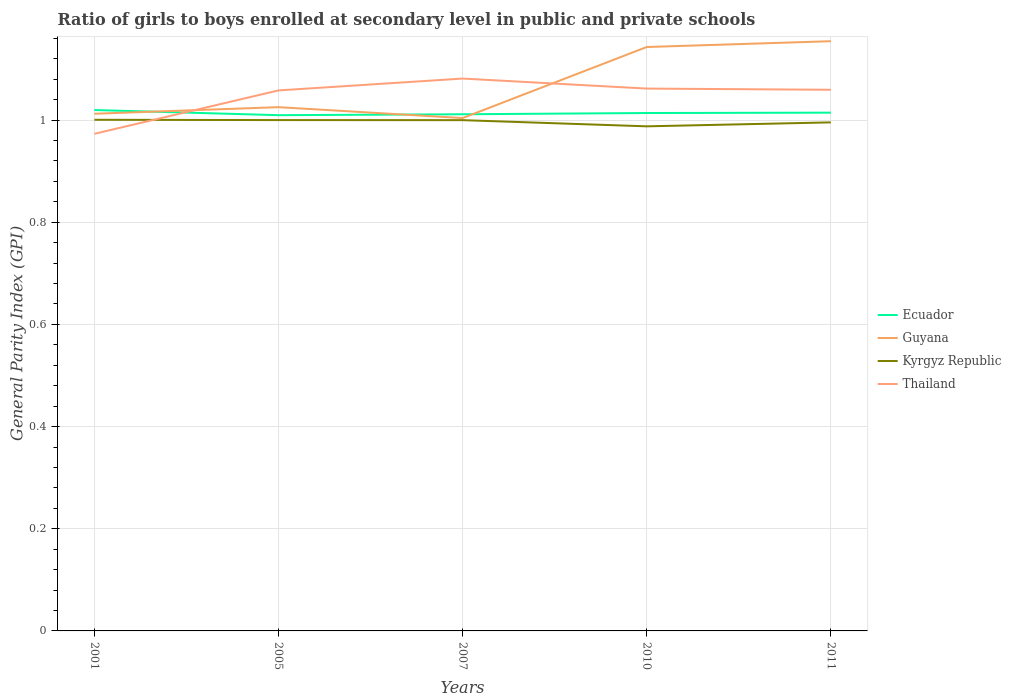How many different coloured lines are there?
Ensure brevity in your answer.  4. Is the number of lines equal to the number of legend labels?
Your answer should be compact. Yes. Across all years, what is the maximum general parity index in Ecuador?
Make the answer very short. 1.01. In which year was the general parity index in Kyrgyz Republic maximum?
Offer a terse response. 2010. What is the total general parity index in Guyana in the graph?
Provide a short and direct response. -0.13. What is the difference between the highest and the second highest general parity index in Kyrgyz Republic?
Your response must be concise. 0.01. What is the difference between the highest and the lowest general parity index in Thailand?
Your response must be concise. 4. What is the difference between two consecutive major ticks on the Y-axis?
Ensure brevity in your answer.  0.2. Does the graph contain any zero values?
Keep it short and to the point. No. Does the graph contain grids?
Provide a short and direct response. Yes. Where does the legend appear in the graph?
Provide a succinct answer. Center right. How many legend labels are there?
Keep it short and to the point. 4. What is the title of the graph?
Your answer should be very brief. Ratio of girls to boys enrolled at secondary level in public and private schools. What is the label or title of the Y-axis?
Offer a terse response. General Parity Index (GPI). What is the General Parity Index (GPI) in Ecuador in 2001?
Provide a short and direct response. 1.02. What is the General Parity Index (GPI) of Guyana in 2001?
Your response must be concise. 1.01. What is the General Parity Index (GPI) of Kyrgyz Republic in 2001?
Make the answer very short. 1. What is the General Parity Index (GPI) in Thailand in 2001?
Give a very brief answer. 0.97. What is the General Parity Index (GPI) in Ecuador in 2005?
Provide a succinct answer. 1.01. What is the General Parity Index (GPI) of Guyana in 2005?
Offer a terse response. 1.03. What is the General Parity Index (GPI) of Kyrgyz Republic in 2005?
Ensure brevity in your answer.  1. What is the General Parity Index (GPI) in Thailand in 2005?
Give a very brief answer. 1.06. What is the General Parity Index (GPI) in Ecuador in 2007?
Give a very brief answer. 1.01. What is the General Parity Index (GPI) in Guyana in 2007?
Make the answer very short. 1. What is the General Parity Index (GPI) of Kyrgyz Republic in 2007?
Keep it short and to the point. 1. What is the General Parity Index (GPI) of Thailand in 2007?
Your answer should be very brief. 1.08. What is the General Parity Index (GPI) in Ecuador in 2010?
Ensure brevity in your answer.  1.01. What is the General Parity Index (GPI) in Guyana in 2010?
Provide a short and direct response. 1.14. What is the General Parity Index (GPI) of Kyrgyz Republic in 2010?
Provide a succinct answer. 0.99. What is the General Parity Index (GPI) in Thailand in 2010?
Give a very brief answer. 1.06. What is the General Parity Index (GPI) of Ecuador in 2011?
Give a very brief answer. 1.01. What is the General Parity Index (GPI) of Guyana in 2011?
Offer a terse response. 1.15. What is the General Parity Index (GPI) in Kyrgyz Republic in 2011?
Make the answer very short. 1. What is the General Parity Index (GPI) of Thailand in 2011?
Provide a short and direct response. 1.06. Across all years, what is the maximum General Parity Index (GPI) of Ecuador?
Provide a short and direct response. 1.02. Across all years, what is the maximum General Parity Index (GPI) in Guyana?
Offer a terse response. 1.15. Across all years, what is the maximum General Parity Index (GPI) in Kyrgyz Republic?
Your answer should be very brief. 1. Across all years, what is the maximum General Parity Index (GPI) in Thailand?
Provide a short and direct response. 1.08. Across all years, what is the minimum General Parity Index (GPI) of Ecuador?
Make the answer very short. 1.01. Across all years, what is the minimum General Parity Index (GPI) of Guyana?
Make the answer very short. 1. Across all years, what is the minimum General Parity Index (GPI) of Kyrgyz Republic?
Your answer should be very brief. 0.99. Across all years, what is the minimum General Parity Index (GPI) of Thailand?
Your answer should be very brief. 0.97. What is the total General Parity Index (GPI) in Ecuador in the graph?
Keep it short and to the point. 5.07. What is the total General Parity Index (GPI) in Guyana in the graph?
Your answer should be very brief. 5.34. What is the total General Parity Index (GPI) in Kyrgyz Republic in the graph?
Offer a very short reply. 4.98. What is the total General Parity Index (GPI) in Thailand in the graph?
Give a very brief answer. 5.23. What is the difference between the General Parity Index (GPI) of Ecuador in 2001 and that in 2005?
Keep it short and to the point. 0.01. What is the difference between the General Parity Index (GPI) in Guyana in 2001 and that in 2005?
Your response must be concise. -0.01. What is the difference between the General Parity Index (GPI) of Kyrgyz Republic in 2001 and that in 2005?
Give a very brief answer. 0. What is the difference between the General Parity Index (GPI) of Thailand in 2001 and that in 2005?
Provide a short and direct response. -0.09. What is the difference between the General Parity Index (GPI) of Ecuador in 2001 and that in 2007?
Give a very brief answer. 0.01. What is the difference between the General Parity Index (GPI) in Guyana in 2001 and that in 2007?
Offer a terse response. 0.01. What is the difference between the General Parity Index (GPI) in Kyrgyz Republic in 2001 and that in 2007?
Ensure brevity in your answer.  0. What is the difference between the General Parity Index (GPI) in Thailand in 2001 and that in 2007?
Provide a short and direct response. -0.11. What is the difference between the General Parity Index (GPI) in Ecuador in 2001 and that in 2010?
Your answer should be very brief. 0.01. What is the difference between the General Parity Index (GPI) in Guyana in 2001 and that in 2010?
Give a very brief answer. -0.13. What is the difference between the General Parity Index (GPI) of Kyrgyz Republic in 2001 and that in 2010?
Ensure brevity in your answer.  0.01. What is the difference between the General Parity Index (GPI) of Thailand in 2001 and that in 2010?
Provide a succinct answer. -0.09. What is the difference between the General Parity Index (GPI) in Ecuador in 2001 and that in 2011?
Your response must be concise. 0.01. What is the difference between the General Parity Index (GPI) of Guyana in 2001 and that in 2011?
Make the answer very short. -0.14. What is the difference between the General Parity Index (GPI) in Kyrgyz Republic in 2001 and that in 2011?
Ensure brevity in your answer.  0.01. What is the difference between the General Parity Index (GPI) of Thailand in 2001 and that in 2011?
Offer a terse response. -0.09. What is the difference between the General Parity Index (GPI) in Ecuador in 2005 and that in 2007?
Provide a succinct answer. -0. What is the difference between the General Parity Index (GPI) of Guyana in 2005 and that in 2007?
Offer a terse response. 0.02. What is the difference between the General Parity Index (GPI) in Kyrgyz Republic in 2005 and that in 2007?
Your answer should be compact. 0. What is the difference between the General Parity Index (GPI) of Thailand in 2005 and that in 2007?
Your answer should be very brief. -0.02. What is the difference between the General Parity Index (GPI) in Ecuador in 2005 and that in 2010?
Your response must be concise. -0. What is the difference between the General Parity Index (GPI) of Guyana in 2005 and that in 2010?
Your answer should be very brief. -0.12. What is the difference between the General Parity Index (GPI) of Kyrgyz Republic in 2005 and that in 2010?
Offer a terse response. 0.01. What is the difference between the General Parity Index (GPI) in Thailand in 2005 and that in 2010?
Ensure brevity in your answer.  -0. What is the difference between the General Parity Index (GPI) in Ecuador in 2005 and that in 2011?
Keep it short and to the point. -0. What is the difference between the General Parity Index (GPI) in Guyana in 2005 and that in 2011?
Offer a terse response. -0.13. What is the difference between the General Parity Index (GPI) in Kyrgyz Republic in 2005 and that in 2011?
Provide a short and direct response. 0. What is the difference between the General Parity Index (GPI) in Thailand in 2005 and that in 2011?
Your answer should be very brief. -0. What is the difference between the General Parity Index (GPI) of Ecuador in 2007 and that in 2010?
Provide a succinct answer. -0. What is the difference between the General Parity Index (GPI) of Guyana in 2007 and that in 2010?
Provide a short and direct response. -0.14. What is the difference between the General Parity Index (GPI) in Kyrgyz Republic in 2007 and that in 2010?
Provide a short and direct response. 0.01. What is the difference between the General Parity Index (GPI) in Thailand in 2007 and that in 2010?
Your response must be concise. 0.02. What is the difference between the General Parity Index (GPI) in Ecuador in 2007 and that in 2011?
Your answer should be very brief. -0. What is the difference between the General Parity Index (GPI) in Guyana in 2007 and that in 2011?
Your answer should be very brief. -0.15. What is the difference between the General Parity Index (GPI) of Kyrgyz Republic in 2007 and that in 2011?
Your answer should be very brief. 0. What is the difference between the General Parity Index (GPI) in Thailand in 2007 and that in 2011?
Give a very brief answer. 0.02. What is the difference between the General Parity Index (GPI) in Ecuador in 2010 and that in 2011?
Offer a very short reply. -0. What is the difference between the General Parity Index (GPI) of Guyana in 2010 and that in 2011?
Your answer should be very brief. -0.01. What is the difference between the General Parity Index (GPI) of Kyrgyz Republic in 2010 and that in 2011?
Give a very brief answer. -0.01. What is the difference between the General Parity Index (GPI) of Thailand in 2010 and that in 2011?
Ensure brevity in your answer.  0. What is the difference between the General Parity Index (GPI) of Ecuador in 2001 and the General Parity Index (GPI) of Guyana in 2005?
Make the answer very short. -0.01. What is the difference between the General Parity Index (GPI) in Ecuador in 2001 and the General Parity Index (GPI) in Kyrgyz Republic in 2005?
Offer a terse response. 0.02. What is the difference between the General Parity Index (GPI) of Ecuador in 2001 and the General Parity Index (GPI) of Thailand in 2005?
Your answer should be very brief. -0.04. What is the difference between the General Parity Index (GPI) of Guyana in 2001 and the General Parity Index (GPI) of Kyrgyz Republic in 2005?
Offer a very short reply. 0.01. What is the difference between the General Parity Index (GPI) of Guyana in 2001 and the General Parity Index (GPI) of Thailand in 2005?
Keep it short and to the point. -0.05. What is the difference between the General Parity Index (GPI) in Kyrgyz Republic in 2001 and the General Parity Index (GPI) in Thailand in 2005?
Your answer should be very brief. -0.06. What is the difference between the General Parity Index (GPI) of Ecuador in 2001 and the General Parity Index (GPI) of Guyana in 2007?
Offer a terse response. 0.02. What is the difference between the General Parity Index (GPI) of Ecuador in 2001 and the General Parity Index (GPI) of Kyrgyz Republic in 2007?
Give a very brief answer. 0.02. What is the difference between the General Parity Index (GPI) of Ecuador in 2001 and the General Parity Index (GPI) of Thailand in 2007?
Your answer should be compact. -0.06. What is the difference between the General Parity Index (GPI) in Guyana in 2001 and the General Parity Index (GPI) in Kyrgyz Republic in 2007?
Your answer should be very brief. 0.01. What is the difference between the General Parity Index (GPI) in Guyana in 2001 and the General Parity Index (GPI) in Thailand in 2007?
Provide a succinct answer. -0.07. What is the difference between the General Parity Index (GPI) of Kyrgyz Republic in 2001 and the General Parity Index (GPI) of Thailand in 2007?
Ensure brevity in your answer.  -0.08. What is the difference between the General Parity Index (GPI) in Ecuador in 2001 and the General Parity Index (GPI) in Guyana in 2010?
Provide a short and direct response. -0.12. What is the difference between the General Parity Index (GPI) of Ecuador in 2001 and the General Parity Index (GPI) of Kyrgyz Republic in 2010?
Offer a terse response. 0.03. What is the difference between the General Parity Index (GPI) in Ecuador in 2001 and the General Parity Index (GPI) in Thailand in 2010?
Make the answer very short. -0.04. What is the difference between the General Parity Index (GPI) of Guyana in 2001 and the General Parity Index (GPI) of Kyrgyz Republic in 2010?
Keep it short and to the point. 0.02. What is the difference between the General Parity Index (GPI) in Guyana in 2001 and the General Parity Index (GPI) in Thailand in 2010?
Offer a very short reply. -0.05. What is the difference between the General Parity Index (GPI) in Kyrgyz Republic in 2001 and the General Parity Index (GPI) in Thailand in 2010?
Your answer should be compact. -0.06. What is the difference between the General Parity Index (GPI) of Ecuador in 2001 and the General Parity Index (GPI) of Guyana in 2011?
Provide a short and direct response. -0.13. What is the difference between the General Parity Index (GPI) of Ecuador in 2001 and the General Parity Index (GPI) of Kyrgyz Republic in 2011?
Your answer should be very brief. 0.02. What is the difference between the General Parity Index (GPI) in Ecuador in 2001 and the General Parity Index (GPI) in Thailand in 2011?
Your response must be concise. -0.04. What is the difference between the General Parity Index (GPI) in Guyana in 2001 and the General Parity Index (GPI) in Kyrgyz Republic in 2011?
Give a very brief answer. 0.02. What is the difference between the General Parity Index (GPI) in Guyana in 2001 and the General Parity Index (GPI) in Thailand in 2011?
Provide a succinct answer. -0.05. What is the difference between the General Parity Index (GPI) in Kyrgyz Republic in 2001 and the General Parity Index (GPI) in Thailand in 2011?
Your answer should be compact. -0.06. What is the difference between the General Parity Index (GPI) in Ecuador in 2005 and the General Parity Index (GPI) in Guyana in 2007?
Provide a succinct answer. 0.01. What is the difference between the General Parity Index (GPI) in Ecuador in 2005 and the General Parity Index (GPI) in Kyrgyz Republic in 2007?
Ensure brevity in your answer.  0.01. What is the difference between the General Parity Index (GPI) in Ecuador in 2005 and the General Parity Index (GPI) in Thailand in 2007?
Offer a terse response. -0.07. What is the difference between the General Parity Index (GPI) in Guyana in 2005 and the General Parity Index (GPI) in Kyrgyz Republic in 2007?
Give a very brief answer. 0.03. What is the difference between the General Parity Index (GPI) of Guyana in 2005 and the General Parity Index (GPI) of Thailand in 2007?
Provide a succinct answer. -0.06. What is the difference between the General Parity Index (GPI) of Kyrgyz Republic in 2005 and the General Parity Index (GPI) of Thailand in 2007?
Your answer should be compact. -0.08. What is the difference between the General Parity Index (GPI) in Ecuador in 2005 and the General Parity Index (GPI) in Guyana in 2010?
Offer a very short reply. -0.13. What is the difference between the General Parity Index (GPI) of Ecuador in 2005 and the General Parity Index (GPI) of Kyrgyz Republic in 2010?
Your answer should be compact. 0.02. What is the difference between the General Parity Index (GPI) in Ecuador in 2005 and the General Parity Index (GPI) in Thailand in 2010?
Offer a terse response. -0.05. What is the difference between the General Parity Index (GPI) in Guyana in 2005 and the General Parity Index (GPI) in Kyrgyz Republic in 2010?
Keep it short and to the point. 0.04. What is the difference between the General Parity Index (GPI) of Guyana in 2005 and the General Parity Index (GPI) of Thailand in 2010?
Make the answer very short. -0.04. What is the difference between the General Parity Index (GPI) of Kyrgyz Republic in 2005 and the General Parity Index (GPI) of Thailand in 2010?
Your response must be concise. -0.06. What is the difference between the General Parity Index (GPI) of Ecuador in 2005 and the General Parity Index (GPI) of Guyana in 2011?
Your answer should be very brief. -0.14. What is the difference between the General Parity Index (GPI) of Ecuador in 2005 and the General Parity Index (GPI) of Kyrgyz Republic in 2011?
Offer a very short reply. 0.01. What is the difference between the General Parity Index (GPI) in Ecuador in 2005 and the General Parity Index (GPI) in Thailand in 2011?
Give a very brief answer. -0.05. What is the difference between the General Parity Index (GPI) of Guyana in 2005 and the General Parity Index (GPI) of Kyrgyz Republic in 2011?
Give a very brief answer. 0.03. What is the difference between the General Parity Index (GPI) of Guyana in 2005 and the General Parity Index (GPI) of Thailand in 2011?
Provide a short and direct response. -0.03. What is the difference between the General Parity Index (GPI) in Kyrgyz Republic in 2005 and the General Parity Index (GPI) in Thailand in 2011?
Provide a short and direct response. -0.06. What is the difference between the General Parity Index (GPI) of Ecuador in 2007 and the General Parity Index (GPI) of Guyana in 2010?
Offer a very short reply. -0.13. What is the difference between the General Parity Index (GPI) of Ecuador in 2007 and the General Parity Index (GPI) of Kyrgyz Republic in 2010?
Give a very brief answer. 0.02. What is the difference between the General Parity Index (GPI) of Ecuador in 2007 and the General Parity Index (GPI) of Thailand in 2010?
Your answer should be compact. -0.05. What is the difference between the General Parity Index (GPI) in Guyana in 2007 and the General Parity Index (GPI) in Kyrgyz Republic in 2010?
Keep it short and to the point. 0.02. What is the difference between the General Parity Index (GPI) in Guyana in 2007 and the General Parity Index (GPI) in Thailand in 2010?
Your response must be concise. -0.06. What is the difference between the General Parity Index (GPI) of Kyrgyz Republic in 2007 and the General Parity Index (GPI) of Thailand in 2010?
Offer a terse response. -0.06. What is the difference between the General Parity Index (GPI) in Ecuador in 2007 and the General Parity Index (GPI) in Guyana in 2011?
Your answer should be compact. -0.14. What is the difference between the General Parity Index (GPI) of Ecuador in 2007 and the General Parity Index (GPI) of Kyrgyz Republic in 2011?
Offer a terse response. 0.02. What is the difference between the General Parity Index (GPI) in Ecuador in 2007 and the General Parity Index (GPI) in Thailand in 2011?
Keep it short and to the point. -0.05. What is the difference between the General Parity Index (GPI) of Guyana in 2007 and the General Parity Index (GPI) of Kyrgyz Republic in 2011?
Your response must be concise. 0.01. What is the difference between the General Parity Index (GPI) of Guyana in 2007 and the General Parity Index (GPI) of Thailand in 2011?
Your answer should be compact. -0.06. What is the difference between the General Parity Index (GPI) of Kyrgyz Republic in 2007 and the General Parity Index (GPI) of Thailand in 2011?
Provide a short and direct response. -0.06. What is the difference between the General Parity Index (GPI) of Ecuador in 2010 and the General Parity Index (GPI) of Guyana in 2011?
Ensure brevity in your answer.  -0.14. What is the difference between the General Parity Index (GPI) in Ecuador in 2010 and the General Parity Index (GPI) in Kyrgyz Republic in 2011?
Your answer should be compact. 0.02. What is the difference between the General Parity Index (GPI) in Ecuador in 2010 and the General Parity Index (GPI) in Thailand in 2011?
Your answer should be very brief. -0.05. What is the difference between the General Parity Index (GPI) of Guyana in 2010 and the General Parity Index (GPI) of Kyrgyz Republic in 2011?
Make the answer very short. 0.15. What is the difference between the General Parity Index (GPI) of Guyana in 2010 and the General Parity Index (GPI) of Thailand in 2011?
Ensure brevity in your answer.  0.08. What is the difference between the General Parity Index (GPI) of Kyrgyz Republic in 2010 and the General Parity Index (GPI) of Thailand in 2011?
Your response must be concise. -0.07. What is the average General Parity Index (GPI) in Ecuador per year?
Ensure brevity in your answer.  1.01. What is the average General Parity Index (GPI) of Guyana per year?
Offer a terse response. 1.07. What is the average General Parity Index (GPI) in Kyrgyz Republic per year?
Your answer should be very brief. 1. What is the average General Parity Index (GPI) in Thailand per year?
Keep it short and to the point. 1.05. In the year 2001, what is the difference between the General Parity Index (GPI) of Ecuador and General Parity Index (GPI) of Guyana?
Provide a short and direct response. 0.01. In the year 2001, what is the difference between the General Parity Index (GPI) of Ecuador and General Parity Index (GPI) of Kyrgyz Republic?
Give a very brief answer. 0.02. In the year 2001, what is the difference between the General Parity Index (GPI) of Ecuador and General Parity Index (GPI) of Thailand?
Your answer should be very brief. 0.05. In the year 2001, what is the difference between the General Parity Index (GPI) of Guyana and General Parity Index (GPI) of Kyrgyz Republic?
Offer a very short reply. 0.01. In the year 2001, what is the difference between the General Parity Index (GPI) in Guyana and General Parity Index (GPI) in Thailand?
Provide a short and direct response. 0.04. In the year 2001, what is the difference between the General Parity Index (GPI) of Kyrgyz Republic and General Parity Index (GPI) of Thailand?
Ensure brevity in your answer.  0.03. In the year 2005, what is the difference between the General Parity Index (GPI) in Ecuador and General Parity Index (GPI) in Guyana?
Provide a succinct answer. -0.02. In the year 2005, what is the difference between the General Parity Index (GPI) of Ecuador and General Parity Index (GPI) of Kyrgyz Republic?
Keep it short and to the point. 0.01. In the year 2005, what is the difference between the General Parity Index (GPI) of Ecuador and General Parity Index (GPI) of Thailand?
Your response must be concise. -0.05. In the year 2005, what is the difference between the General Parity Index (GPI) in Guyana and General Parity Index (GPI) in Kyrgyz Republic?
Provide a short and direct response. 0.03. In the year 2005, what is the difference between the General Parity Index (GPI) in Guyana and General Parity Index (GPI) in Thailand?
Offer a terse response. -0.03. In the year 2005, what is the difference between the General Parity Index (GPI) in Kyrgyz Republic and General Parity Index (GPI) in Thailand?
Provide a succinct answer. -0.06. In the year 2007, what is the difference between the General Parity Index (GPI) in Ecuador and General Parity Index (GPI) in Guyana?
Your answer should be very brief. 0.01. In the year 2007, what is the difference between the General Parity Index (GPI) in Ecuador and General Parity Index (GPI) in Kyrgyz Republic?
Ensure brevity in your answer.  0.01. In the year 2007, what is the difference between the General Parity Index (GPI) in Ecuador and General Parity Index (GPI) in Thailand?
Your answer should be very brief. -0.07. In the year 2007, what is the difference between the General Parity Index (GPI) in Guyana and General Parity Index (GPI) in Kyrgyz Republic?
Provide a short and direct response. 0. In the year 2007, what is the difference between the General Parity Index (GPI) in Guyana and General Parity Index (GPI) in Thailand?
Provide a succinct answer. -0.08. In the year 2007, what is the difference between the General Parity Index (GPI) in Kyrgyz Republic and General Parity Index (GPI) in Thailand?
Provide a short and direct response. -0.08. In the year 2010, what is the difference between the General Parity Index (GPI) in Ecuador and General Parity Index (GPI) in Guyana?
Offer a very short reply. -0.13. In the year 2010, what is the difference between the General Parity Index (GPI) in Ecuador and General Parity Index (GPI) in Kyrgyz Republic?
Keep it short and to the point. 0.03. In the year 2010, what is the difference between the General Parity Index (GPI) in Ecuador and General Parity Index (GPI) in Thailand?
Offer a very short reply. -0.05. In the year 2010, what is the difference between the General Parity Index (GPI) in Guyana and General Parity Index (GPI) in Kyrgyz Republic?
Your answer should be very brief. 0.16. In the year 2010, what is the difference between the General Parity Index (GPI) of Guyana and General Parity Index (GPI) of Thailand?
Provide a short and direct response. 0.08. In the year 2010, what is the difference between the General Parity Index (GPI) of Kyrgyz Republic and General Parity Index (GPI) of Thailand?
Give a very brief answer. -0.07. In the year 2011, what is the difference between the General Parity Index (GPI) in Ecuador and General Parity Index (GPI) in Guyana?
Your response must be concise. -0.14. In the year 2011, what is the difference between the General Parity Index (GPI) in Ecuador and General Parity Index (GPI) in Kyrgyz Republic?
Make the answer very short. 0.02. In the year 2011, what is the difference between the General Parity Index (GPI) of Ecuador and General Parity Index (GPI) of Thailand?
Ensure brevity in your answer.  -0.04. In the year 2011, what is the difference between the General Parity Index (GPI) of Guyana and General Parity Index (GPI) of Kyrgyz Republic?
Offer a terse response. 0.16. In the year 2011, what is the difference between the General Parity Index (GPI) in Guyana and General Parity Index (GPI) in Thailand?
Offer a terse response. 0.1. In the year 2011, what is the difference between the General Parity Index (GPI) of Kyrgyz Republic and General Parity Index (GPI) of Thailand?
Give a very brief answer. -0.06. What is the ratio of the General Parity Index (GPI) in Ecuador in 2001 to that in 2005?
Provide a succinct answer. 1.01. What is the ratio of the General Parity Index (GPI) of Guyana in 2001 to that in 2005?
Give a very brief answer. 0.99. What is the ratio of the General Parity Index (GPI) in Kyrgyz Republic in 2001 to that in 2005?
Offer a very short reply. 1. What is the ratio of the General Parity Index (GPI) of Thailand in 2001 to that in 2005?
Your answer should be compact. 0.92. What is the ratio of the General Parity Index (GPI) of Ecuador in 2001 to that in 2007?
Your answer should be compact. 1.01. What is the ratio of the General Parity Index (GPI) in Guyana in 2001 to that in 2007?
Offer a terse response. 1.01. What is the ratio of the General Parity Index (GPI) of Ecuador in 2001 to that in 2010?
Offer a very short reply. 1.01. What is the ratio of the General Parity Index (GPI) in Guyana in 2001 to that in 2010?
Provide a short and direct response. 0.89. What is the ratio of the General Parity Index (GPI) in Kyrgyz Republic in 2001 to that in 2010?
Your answer should be very brief. 1.01. What is the ratio of the General Parity Index (GPI) of Thailand in 2001 to that in 2010?
Offer a terse response. 0.92. What is the ratio of the General Parity Index (GPI) in Ecuador in 2001 to that in 2011?
Your response must be concise. 1.01. What is the ratio of the General Parity Index (GPI) in Guyana in 2001 to that in 2011?
Your answer should be compact. 0.88. What is the ratio of the General Parity Index (GPI) in Thailand in 2001 to that in 2011?
Provide a short and direct response. 0.92. What is the ratio of the General Parity Index (GPI) of Guyana in 2005 to that in 2007?
Provide a short and direct response. 1.02. What is the ratio of the General Parity Index (GPI) in Thailand in 2005 to that in 2007?
Your response must be concise. 0.98. What is the ratio of the General Parity Index (GPI) in Ecuador in 2005 to that in 2010?
Your response must be concise. 1. What is the ratio of the General Parity Index (GPI) of Guyana in 2005 to that in 2010?
Provide a succinct answer. 0.9. What is the ratio of the General Parity Index (GPI) in Kyrgyz Republic in 2005 to that in 2010?
Ensure brevity in your answer.  1.01. What is the ratio of the General Parity Index (GPI) of Guyana in 2005 to that in 2011?
Your response must be concise. 0.89. What is the ratio of the General Parity Index (GPI) of Kyrgyz Republic in 2005 to that in 2011?
Make the answer very short. 1. What is the ratio of the General Parity Index (GPI) in Ecuador in 2007 to that in 2010?
Ensure brevity in your answer.  1. What is the ratio of the General Parity Index (GPI) of Guyana in 2007 to that in 2010?
Offer a terse response. 0.88. What is the ratio of the General Parity Index (GPI) of Kyrgyz Republic in 2007 to that in 2010?
Offer a very short reply. 1.01. What is the ratio of the General Parity Index (GPI) in Thailand in 2007 to that in 2010?
Give a very brief answer. 1.02. What is the ratio of the General Parity Index (GPI) in Ecuador in 2007 to that in 2011?
Offer a terse response. 1. What is the ratio of the General Parity Index (GPI) in Guyana in 2007 to that in 2011?
Your answer should be very brief. 0.87. What is the ratio of the General Parity Index (GPI) of Thailand in 2007 to that in 2011?
Ensure brevity in your answer.  1.02. What is the ratio of the General Parity Index (GPI) of Guyana in 2010 to that in 2011?
Provide a short and direct response. 0.99. What is the difference between the highest and the second highest General Parity Index (GPI) in Ecuador?
Your response must be concise. 0.01. What is the difference between the highest and the second highest General Parity Index (GPI) in Guyana?
Offer a terse response. 0.01. What is the difference between the highest and the second highest General Parity Index (GPI) of Kyrgyz Republic?
Offer a very short reply. 0. What is the difference between the highest and the second highest General Parity Index (GPI) of Thailand?
Offer a terse response. 0.02. What is the difference between the highest and the lowest General Parity Index (GPI) of Ecuador?
Keep it short and to the point. 0.01. What is the difference between the highest and the lowest General Parity Index (GPI) of Guyana?
Provide a succinct answer. 0.15. What is the difference between the highest and the lowest General Parity Index (GPI) in Kyrgyz Republic?
Provide a short and direct response. 0.01. What is the difference between the highest and the lowest General Parity Index (GPI) of Thailand?
Your response must be concise. 0.11. 